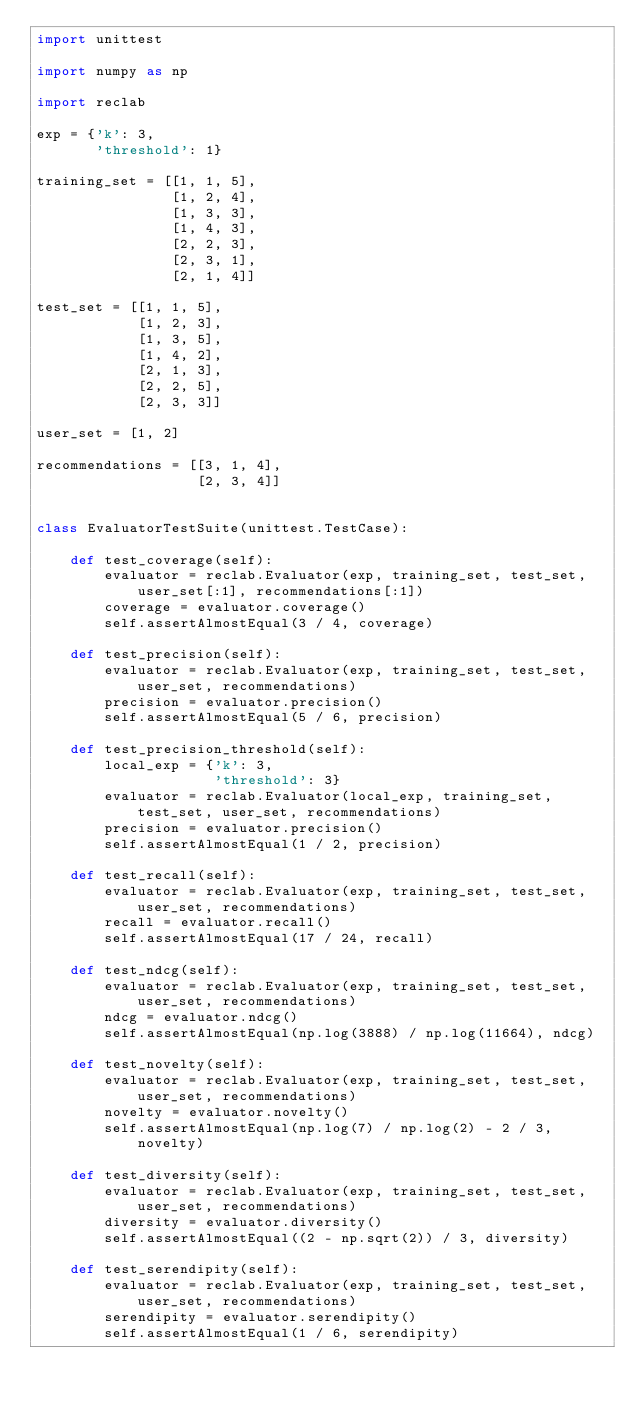Convert code to text. <code><loc_0><loc_0><loc_500><loc_500><_Python_>import unittest

import numpy as np

import reclab

exp = {'k': 3,
       'threshold': 1}

training_set = [[1, 1, 5],
                [1, 2, 4],
                [1, 3, 3],
                [1, 4, 3],
                [2, 2, 3],
                [2, 3, 1],
                [2, 1, 4]]

test_set = [[1, 1, 5],
            [1, 2, 3],
            [1, 3, 5],
            [1, 4, 2],
            [2, 1, 3],
            [2, 2, 5],
            [2, 3, 3]]

user_set = [1, 2]

recommendations = [[3, 1, 4],
                   [2, 3, 4]]


class EvaluatorTestSuite(unittest.TestCase):

    def test_coverage(self):
        evaluator = reclab.Evaluator(exp, training_set, test_set, user_set[:1], recommendations[:1])
        coverage = evaluator.coverage()
        self.assertAlmostEqual(3 / 4, coverage)

    def test_precision(self):
        evaluator = reclab.Evaluator(exp, training_set, test_set, user_set, recommendations)
        precision = evaluator.precision()
        self.assertAlmostEqual(5 / 6, precision)

    def test_precision_threshold(self):
        local_exp = {'k': 3,
                     'threshold': 3}
        evaluator = reclab.Evaluator(local_exp, training_set, test_set, user_set, recommendations)
        precision = evaluator.precision()
        self.assertAlmostEqual(1 / 2, precision)

    def test_recall(self):
        evaluator = reclab.Evaluator(exp, training_set, test_set, user_set, recommendations)
        recall = evaluator.recall()
        self.assertAlmostEqual(17 / 24, recall)

    def test_ndcg(self):
        evaluator = reclab.Evaluator(exp, training_set, test_set, user_set, recommendations)
        ndcg = evaluator.ndcg()
        self.assertAlmostEqual(np.log(3888) / np.log(11664), ndcg)

    def test_novelty(self):
        evaluator = reclab.Evaluator(exp, training_set, test_set, user_set, recommendations)
        novelty = evaluator.novelty()
        self.assertAlmostEqual(np.log(7) / np.log(2) - 2 / 3, novelty)

    def test_diversity(self):
        evaluator = reclab.Evaluator(exp, training_set, test_set, user_set, recommendations)
        diversity = evaluator.diversity()
        self.assertAlmostEqual((2 - np.sqrt(2)) / 3, diversity)

    def test_serendipity(self):
        evaluator = reclab.Evaluator(exp, training_set, test_set, user_set, recommendations)
        serendipity = evaluator.serendipity()
        self.assertAlmostEqual(1 / 6, serendipity)
</code> 